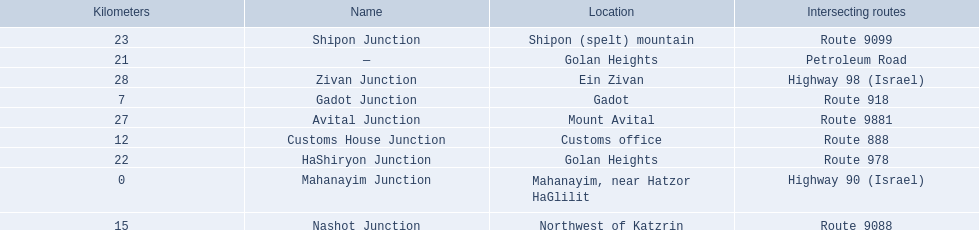Which junctions are located on numbered routes, and not highways or other types? Gadot Junction, Customs House Junction, Nashot Junction, HaShiryon Junction, Shipon Junction, Avital Junction. Of these junctions, which ones are located on routes with four digits (ex. route 9999)? Nashot Junction, Shipon Junction, Avital Junction. Of the remaining routes, which is located on shipon (spelt) mountain? Shipon Junction. 